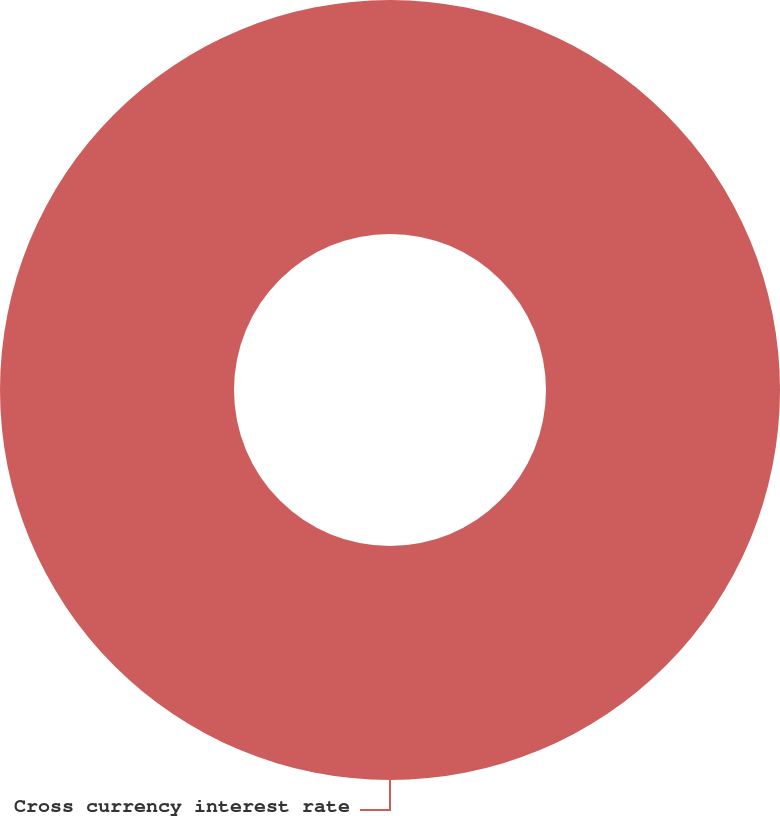Convert chart. <chart><loc_0><loc_0><loc_500><loc_500><pie_chart><fcel>Cross currency interest rate<nl><fcel>100.0%<nl></chart> 